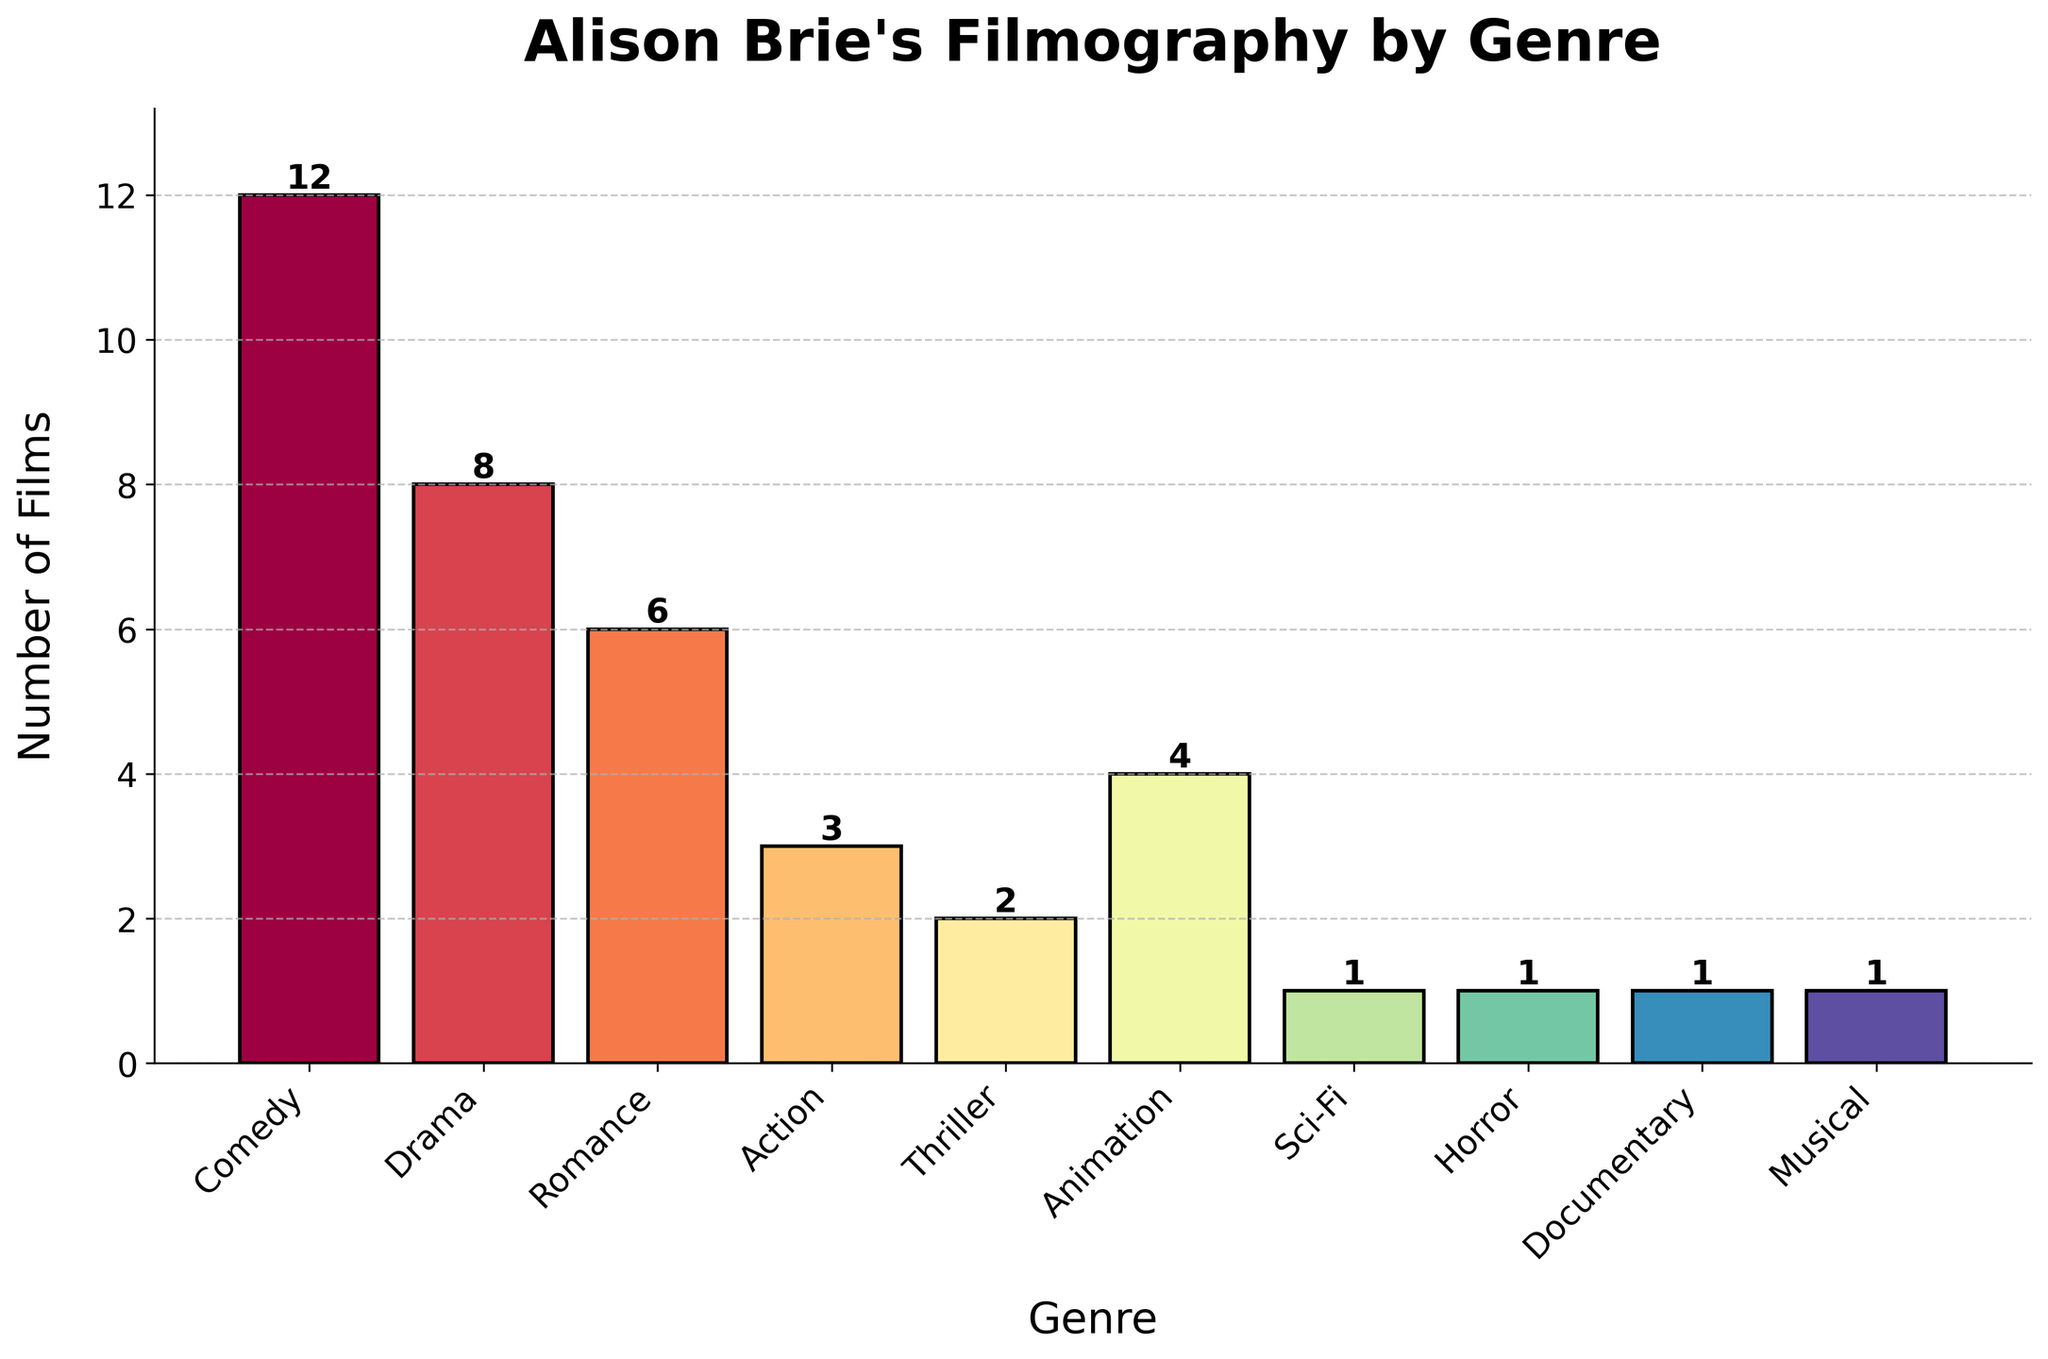Which genre has the most films in Alison Brie's filmography? According to the figure, the highest bar represents 'Comedy', indicating she has the most films in this genre.
Answer: Comedy How many more Comedy films does Alison Brie have compared to Thriller films? The Comedy bar shows 12 films, and the Thriller bar shows 2 films. Subtracting these gives: 12 - 2 = 10
Answer: 10 What is the total number of films Alison Brie has done in the Drama and Romance genres combined? The Drama genre has 8 films, and the Romance genre has 6 films. Adding these together gives: 8 + 6 = 14
Answer: 14 Which genres have the least number of films in Alison Brie's filmography? The shortest bars represent Horror, Sci-Fi, Documentary, and Musical, each with just 1 film.
Answer: Horror, Sci-Fi, Documentary, Musical How does the number of Action films Alison Brie has done compare to the number of Animation films? The Action genre shows 3 films, and the Animation genre shows 4 films. Since 3 is less than 4, she has done fewer Action films than Animation films.
Answer: Action < Animation What is the combined number of films in the genres containing only 1 film each? The bars for Sci-Fi, Horror, Documentary, and Musical categories each show 1 film. Adding these together: 1 + 1 + 1 + 1 = 4
Answer: 4 What percentage of Alison Brie's total films does the Drama genre represent? Alison Brie's total films are sum of all bars: 12 (Comedy) + 8 (Drama) + 6 (Romance) + 3 (Action) + 2 (Thriller) + 4 (Animation) + 1 (Sci-Fi) + 1 (Horror) + 1 (Documentary) + 1 (Musical) = 39. The Drama genre has 8 films. The percentage is (8/39) * 100 ≈ 20.51%
Answer: ~20.51% Which genre's bar is colored most similarly to the Documentary genre's bar? The Documentary bar, colored with a gradient from the Spectral colormap, appears near dark red. The bar for Horror also appears similar in color, suggesting a close hue.
Answer: Horror 